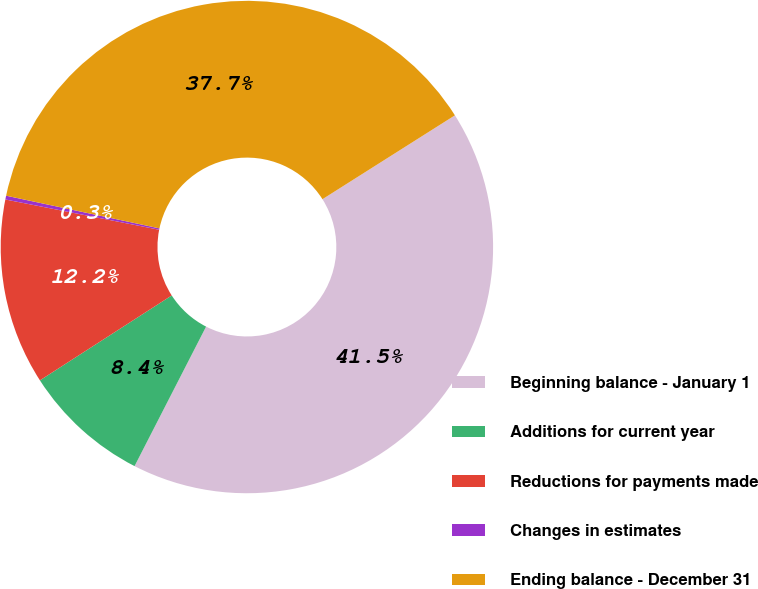<chart> <loc_0><loc_0><loc_500><loc_500><pie_chart><fcel>Beginning balance - January 1<fcel>Additions for current year<fcel>Reductions for payments made<fcel>Changes in estimates<fcel>Ending balance - December 31<nl><fcel>41.52%<fcel>8.35%<fcel>12.2%<fcel>0.25%<fcel>37.67%<nl></chart> 